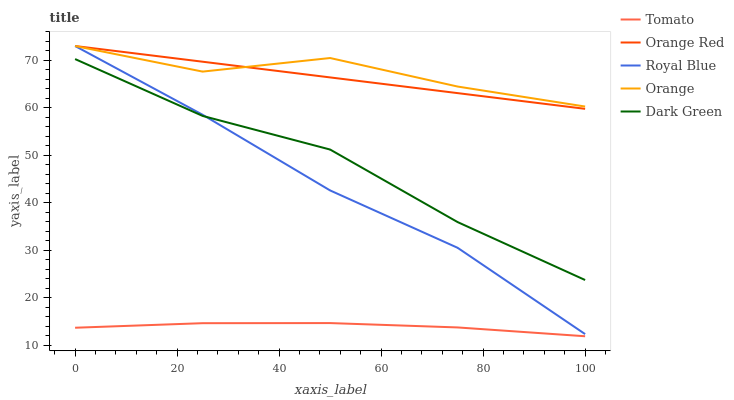Does Tomato have the minimum area under the curve?
Answer yes or no. Yes. Does Orange have the maximum area under the curve?
Answer yes or no. Yes. Does Royal Blue have the minimum area under the curve?
Answer yes or no. No. Does Royal Blue have the maximum area under the curve?
Answer yes or no. No. Is Orange Red the smoothest?
Answer yes or no. Yes. Is Orange the roughest?
Answer yes or no. Yes. Is Royal Blue the smoothest?
Answer yes or no. No. Is Royal Blue the roughest?
Answer yes or no. No. Does Tomato have the lowest value?
Answer yes or no. Yes. Does Royal Blue have the lowest value?
Answer yes or no. No. Does Orange Red have the highest value?
Answer yes or no. Yes. Does Dark Green have the highest value?
Answer yes or no. No. Is Tomato less than Orange Red?
Answer yes or no. Yes. Is Orange Red greater than Dark Green?
Answer yes or no. Yes. Does Orange intersect Orange Red?
Answer yes or no. Yes. Is Orange less than Orange Red?
Answer yes or no. No. Is Orange greater than Orange Red?
Answer yes or no. No. Does Tomato intersect Orange Red?
Answer yes or no. No. 